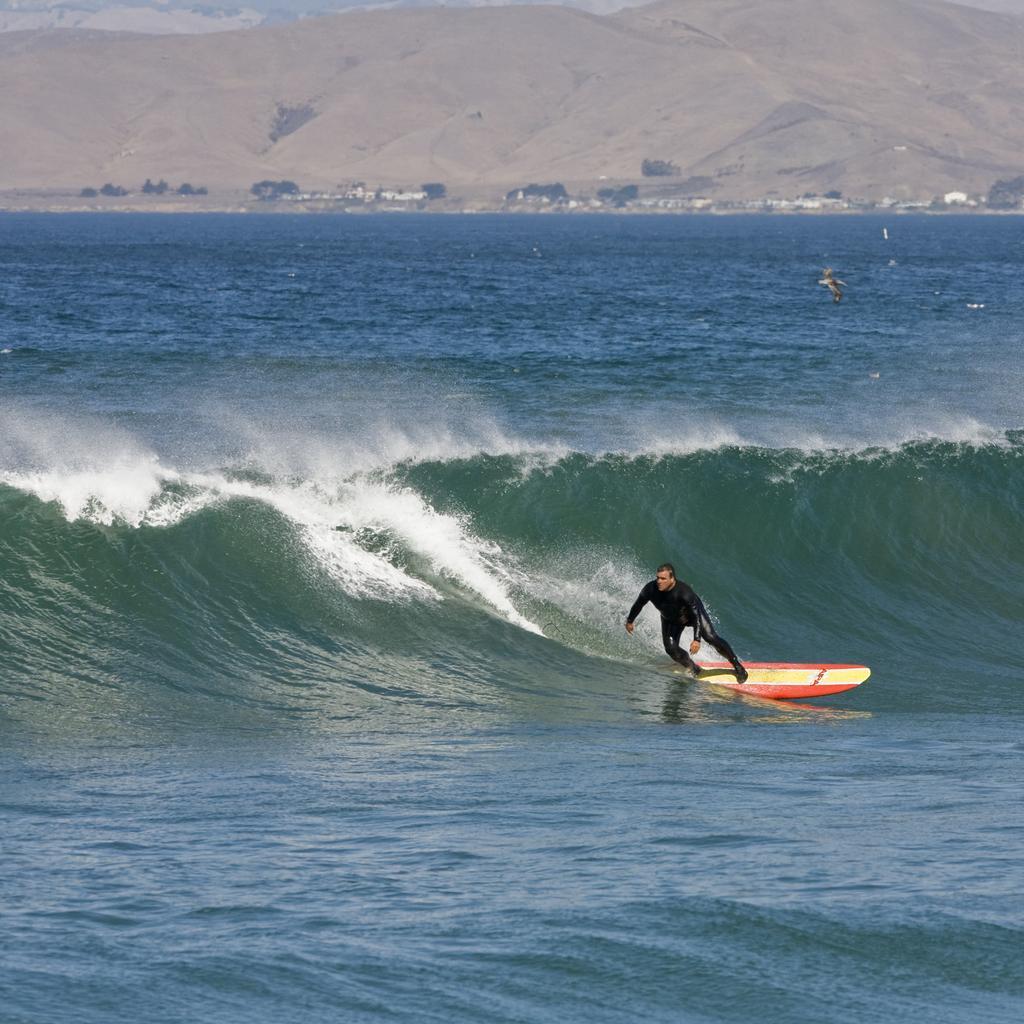How would you summarize this image in a sentence or two? In the image there is a man surfing on the waves of a sea and in the background there are mountains. 